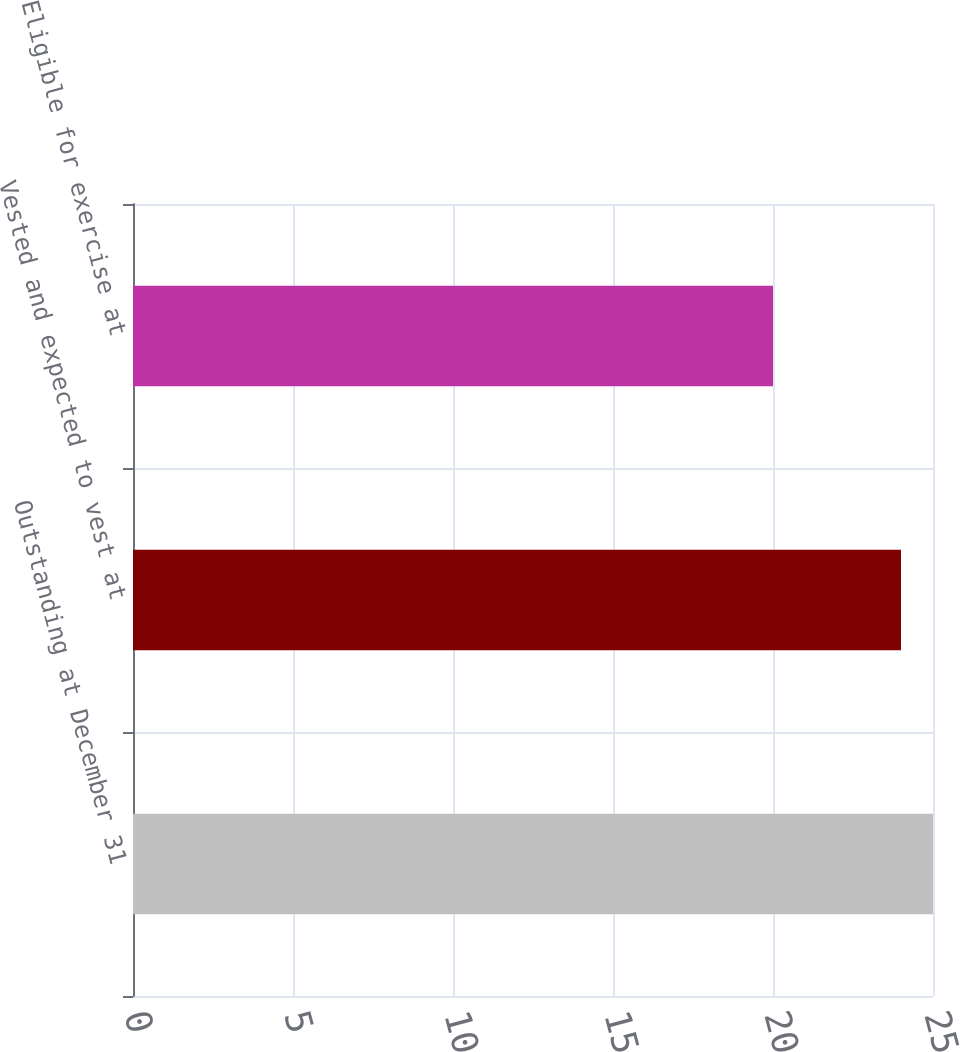Convert chart to OTSL. <chart><loc_0><loc_0><loc_500><loc_500><bar_chart><fcel>Outstanding at December 31<fcel>Vested and expected to vest at<fcel>Eligible for exercise at<nl><fcel>25<fcel>24<fcel>20<nl></chart> 